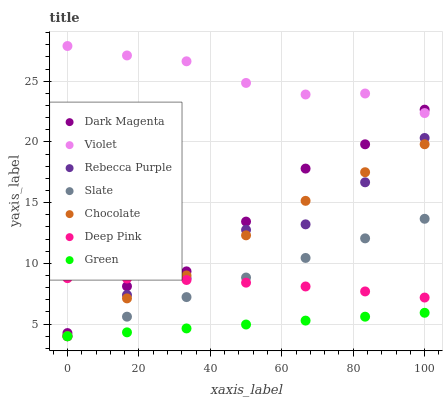Does Green have the minimum area under the curve?
Answer yes or no. Yes. Does Violet have the maximum area under the curve?
Answer yes or no. Yes. Does Dark Magenta have the minimum area under the curve?
Answer yes or no. No. Does Dark Magenta have the maximum area under the curve?
Answer yes or no. No. Is Slate the smoothest?
Answer yes or no. Yes. Is Rebecca Purple the roughest?
Answer yes or no. Yes. Is Dark Magenta the smoothest?
Answer yes or no. No. Is Dark Magenta the roughest?
Answer yes or no. No. Does Slate have the lowest value?
Answer yes or no. Yes. Does Dark Magenta have the lowest value?
Answer yes or no. No. Does Violet have the highest value?
Answer yes or no. Yes. Does Dark Magenta have the highest value?
Answer yes or no. No. Is Chocolate less than Violet?
Answer yes or no. Yes. Is Violet greater than Rebecca Purple?
Answer yes or no. Yes. Does Slate intersect Rebecca Purple?
Answer yes or no. Yes. Is Slate less than Rebecca Purple?
Answer yes or no. No. Is Slate greater than Rebecca Purple?
Answer yes or no. No. Does Chocolate intersect Violet?
Answer yes or no. No. 